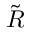Convert formula to latex. <formula><loc_0><loc_0><loc_500><loc_500>\tilde { R }</formula> 